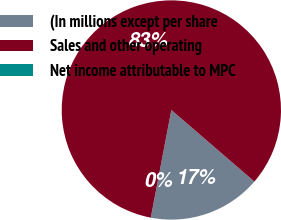Convert chart to OTSL. <chart><loc_0><loc_0><loc_500><loc_500><pie_chart><fcel>(In millions except per share<fcel>Sales and other operating<fcel>Net income attributable to MPC<nl><fcel>16.67%<fcel>83.33%<fcel>0.01%<nl></chart> 